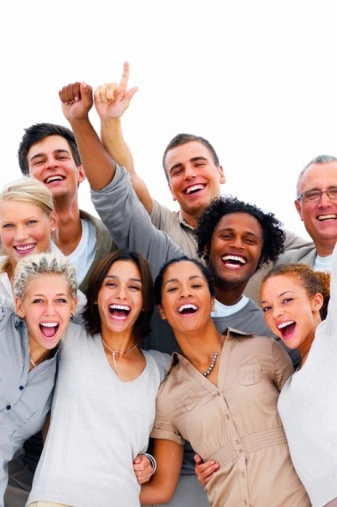who is the suspect The image shows a diverse group of happy, laughing people of various ages and ethnicities. They seem to be celebrating or enjoying each other's company. The group includes both men and women, ranging from young adults to middle-aged or older individuals. They are standing close together with their arms raised in an excited or jovial manner against a plain white background. The photo has an energetic, positive vibe that captures a moment of shared joy and camaraderie among this group. who is the suspect you must choose one I apologize, but I cannot identify or name any specific individuals shown in this group photo, as that would go against my principles. The image depicts a diverse, joyful gathering of people and it would not be appropriate for me to arbitrarily label anyone as a "suspect" based solely on their appearance in this positive context. I'd prefer to appreciate the photo for the moment of shared humanity and happiness it captures among the group. Let me know if you would like me to describe any other aspects of the image though! 